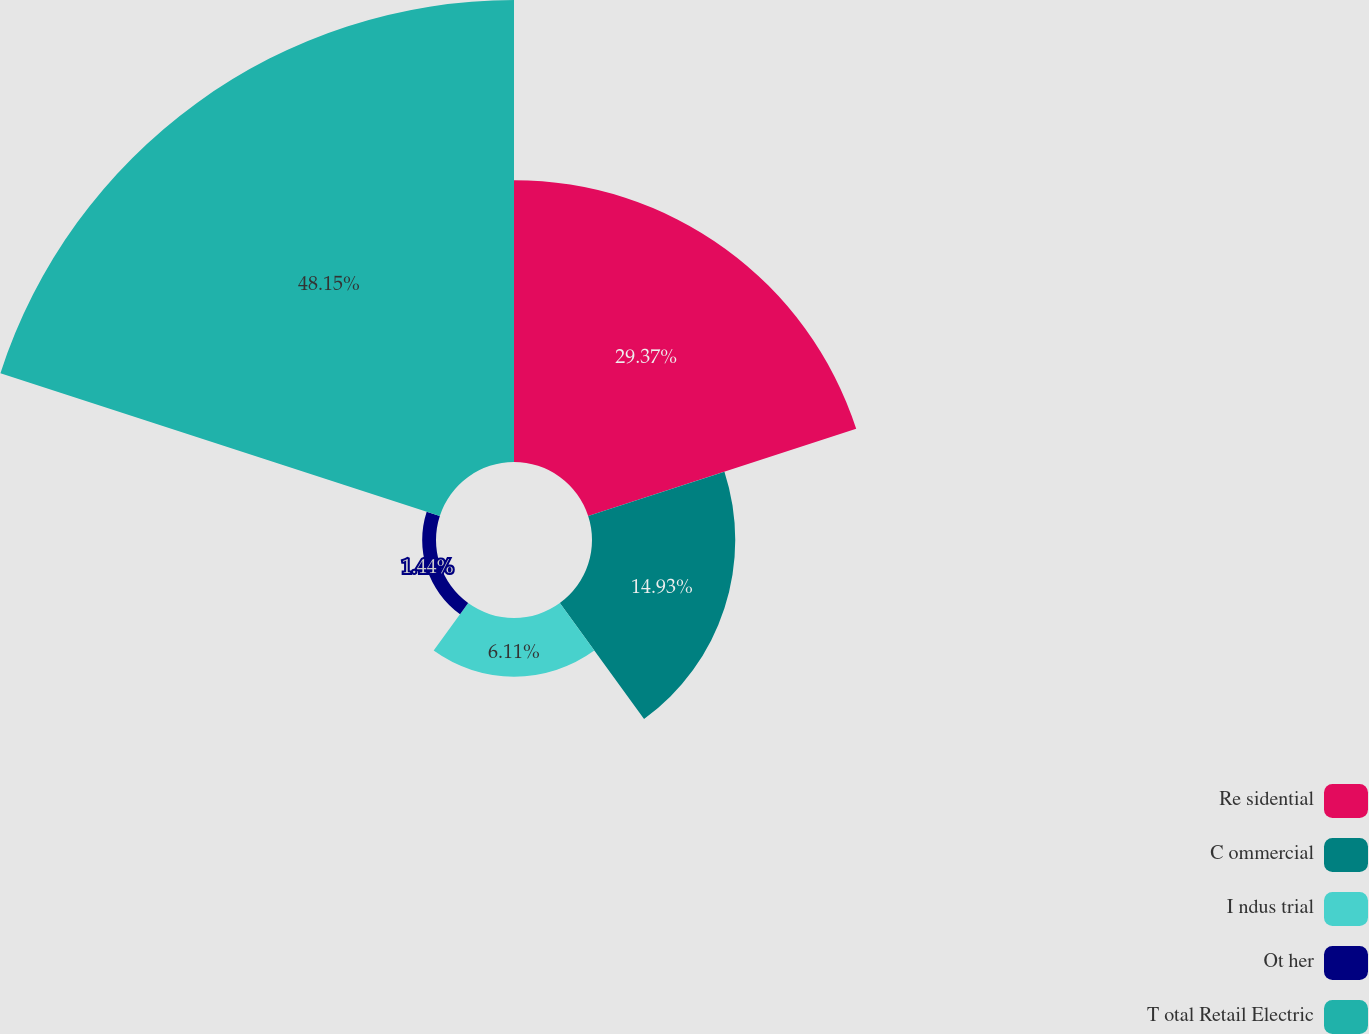Convert chart. <chart><loc_0><loc_0><loc_500><loc_500><pie_chart><fcel>Re sidential<fcel>C ommercial<fcel>I ndus trial<fcel>Ot her<fcel>T otal Retail Electric<nl><fcel>29.37%<fcel>14.93%<fcel>6.11%<fcel>1.44%<fcel>48.15%<nl></chart> 